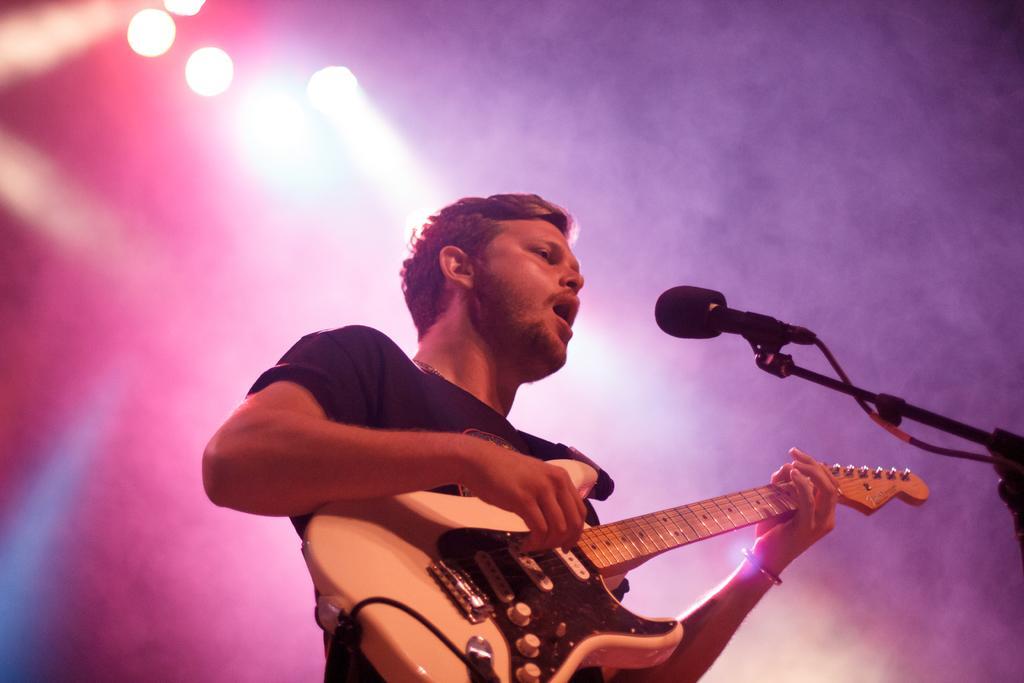Could you give a brief overview of what you see in this image? In this image I can see a man who is playing guitar in front of a microphone. 